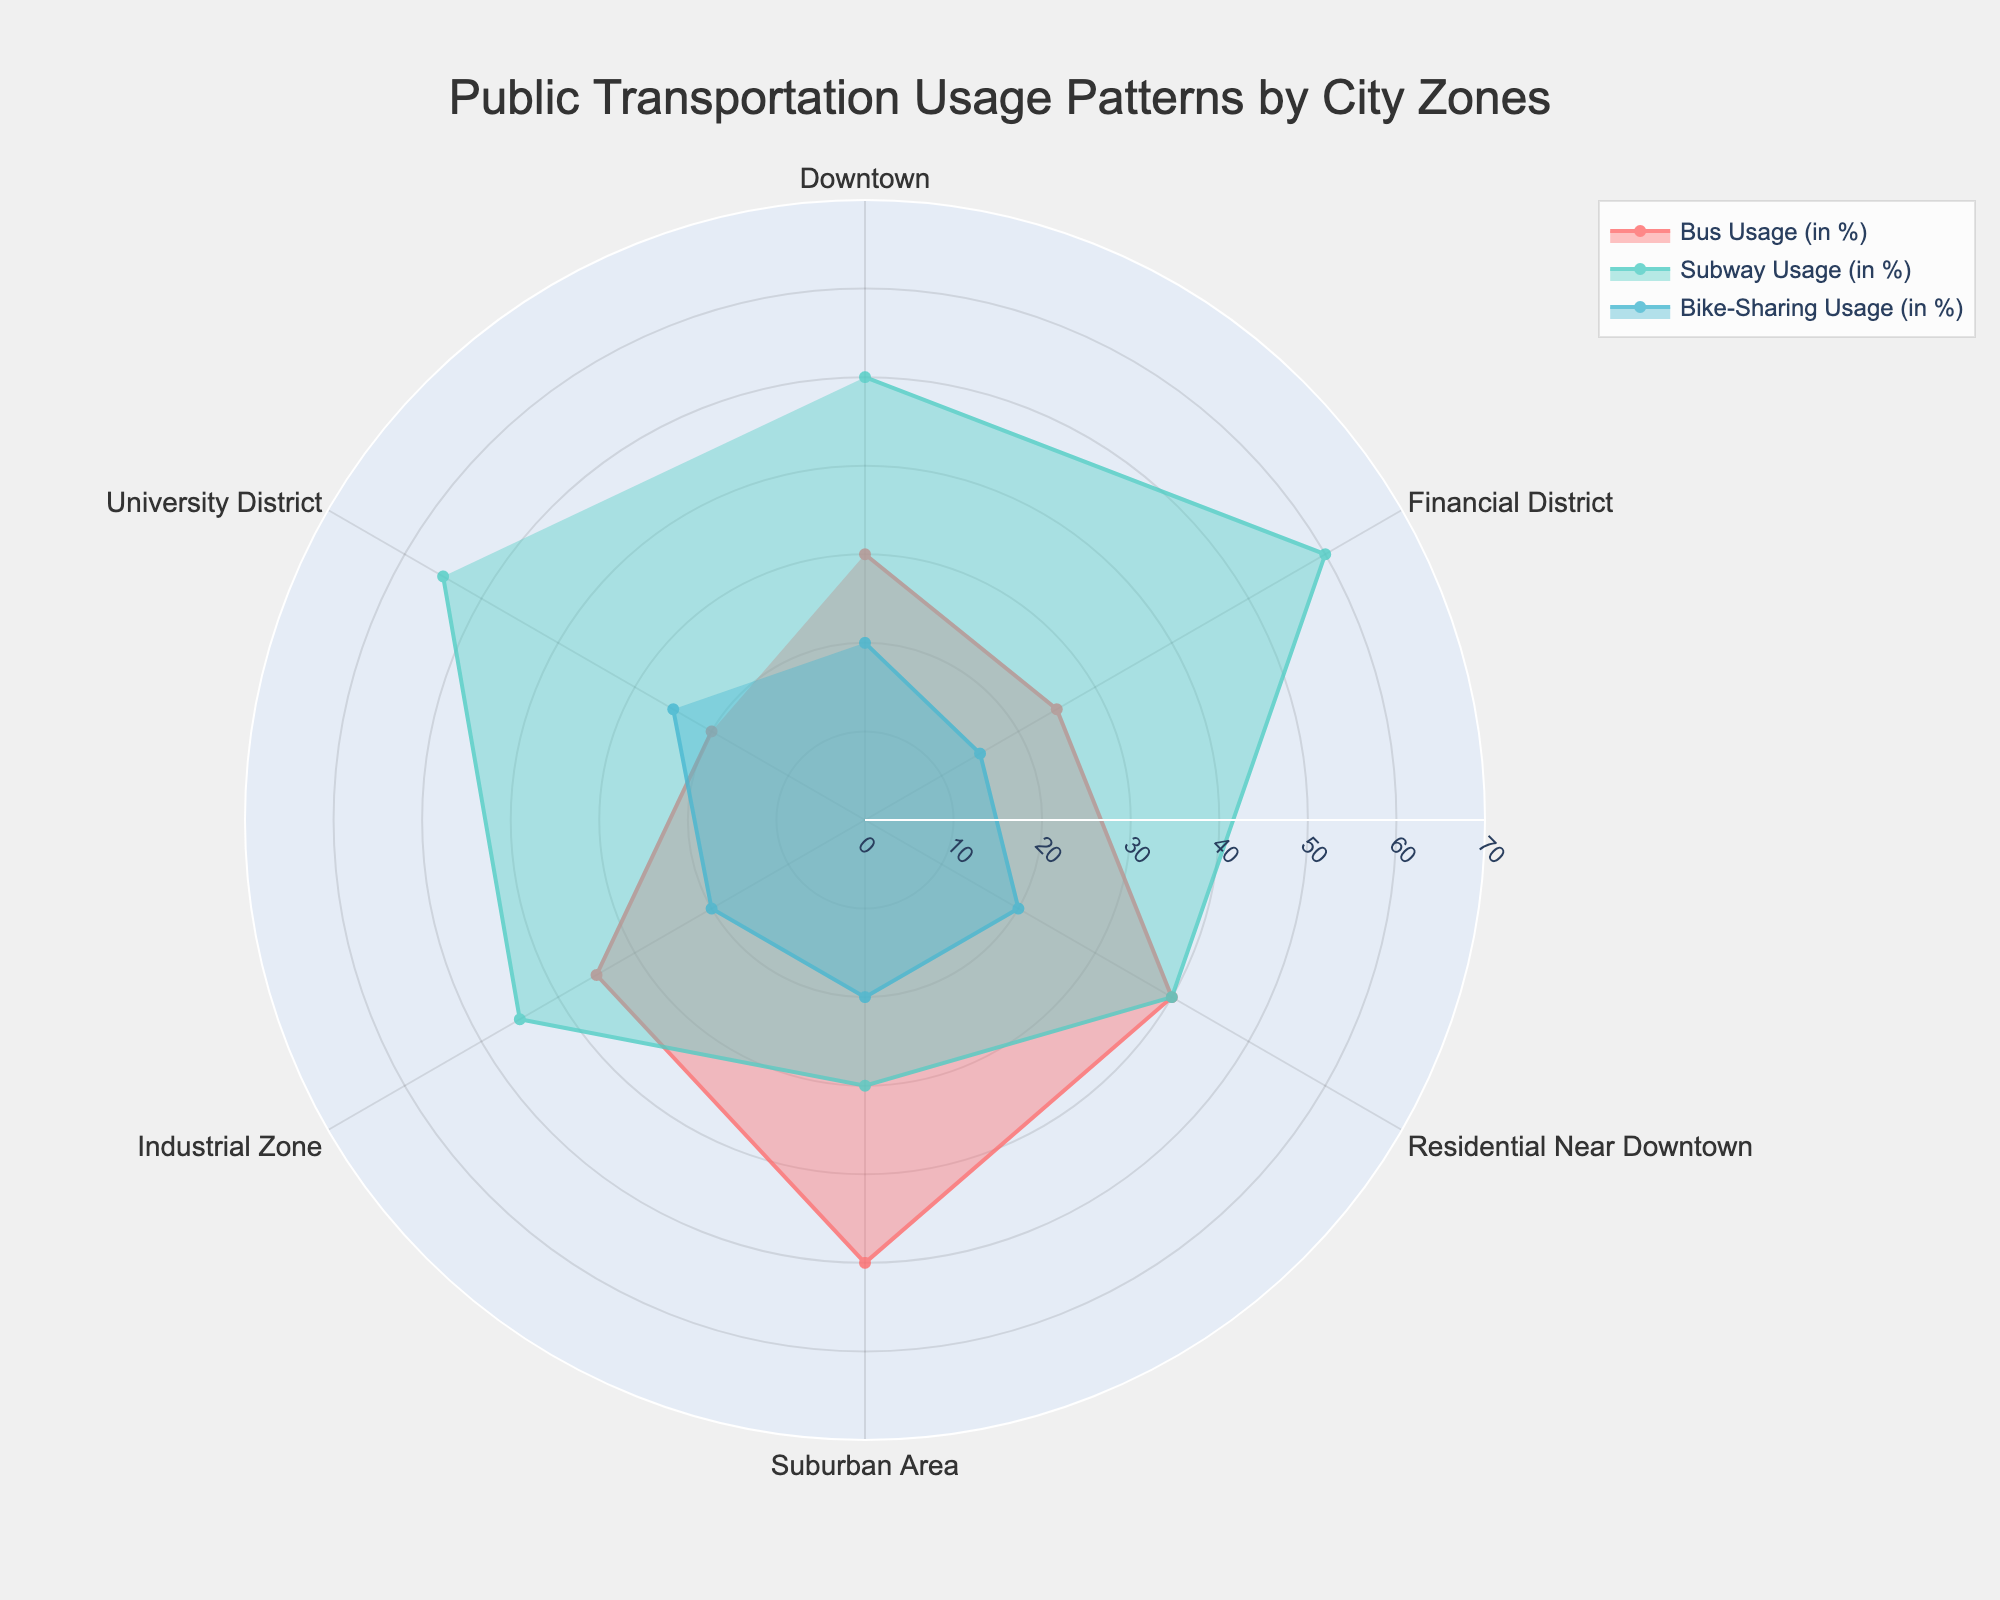What is the title of the figure? The title of the figure is typically displayed at the top. Here, it reads 'Public Transportation Usage Patterns by City Zones'.
Answer: Public Transportation Usage Patterns by City Zones Is the 'Bike-Sharing Usage (in %)' in the Financial District higher or lower than in the Downtown? By comparing the height of the area filled for 'Bike-Sharing Usage (in %)' between the Financial District and Downtown, one can observe that the value in the Financial District is lower than in Downtown.
Answer: Lower Which city zone has the highest 'Subway Usage (in %)'? By looking at the maximum radius of the line corresponding to 'Subway Usage (in %)', it can be seen that the University District has the highest value.
Answer: University District What is the average 'Bus Usage (in %)' across all city zones? To find the average 'Bus Usage (in %)', add all bus usage percentages (30 + 25 + 40 + 50 + 35 + 20) and divide by the number of zones, which is 6. The calculation is (200 / 6) = 33.33.
Answer: 33.33% Which city zone has the equal percentage for Bus Usage and Subway Usage? Identifying the patterns, the Residential Near Downtown zone shows the same value (40%) for both Bus and Subway Usage.
Answer: Residential Near Downtown By how much is the 'Subway Usage (in %)' in the Financial District greater than in the Industrial Zone? The 'Subway Usage (in %)' in the Financial District is 60%, and in the Industrial Zone it is 45%. The difference is 60% - 45% = 15%.
Answer: 15% Which transportation mode has the highest variability across different city zones? To determine the mode with the highest variability, visually assess the fluctuations in the radii of the three different colored areas. The 'Subway Usage (in %)' shows the most fluctuation across zones.
Answer: Subway Usage What is the total 'Bike-Sharing Usage (in %)' for all the city zones combined? Sum the 'Bike-Sharing Usage (in %)' values for all city zones: 20 + 15 + 20 + 20 + 20 + 25 = 120.
Answer: 120 Compare the 'Bus Usage (in %)' between the Downtown and the Suburban Area. Which one is higher, and by how much? The 'Bus Usage (in %)' is 30% in Downtown and 50% in the Suburban Area. The Suburban Area has a higher bus usage by (50% - 30%) = 20%.
Answer: Suburban Area by 20% What is the range of 'Subway Usage (in %)' values across all city zones? Range is calculated by subtracting the smallest value from the largest value in 'Subway Usage (in %)'. The highest value is 60% (Financial District) and the lowest is 30% (Suburban Area), giving a range of 60% - 30% = 30%.
Answer: 30% 